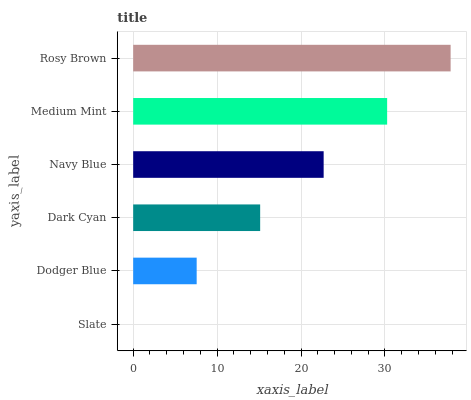Is Slate the minimum?
Answer yes or no. Yes. Is Rosy Brown the maximum?
Answer yes or no. Yes. Is Dodger Blue the minimum?
Answer yes or no. No. Is Dodger Blue the maximum?
Answer yes or no. No. Is Dodger Blue greater than Slate?
Answer yes or no. Yes. Is Slate less than Dodger Blue?
Answer yes or no. Yes. Is Slate greater than Dodger Blue?
Answer yes or no. No. Is Dodger Blue less than Slate?
Answer yes or no. No. Is Navy Blue the high median?
Answer yes or no. Yes. Is Dark Cyan the low median?
Answer yes or no. Yes. Is Medium Mint the high median?
Answer yes or no. No. Is Slate the low median?
Answer yes or no. No. 